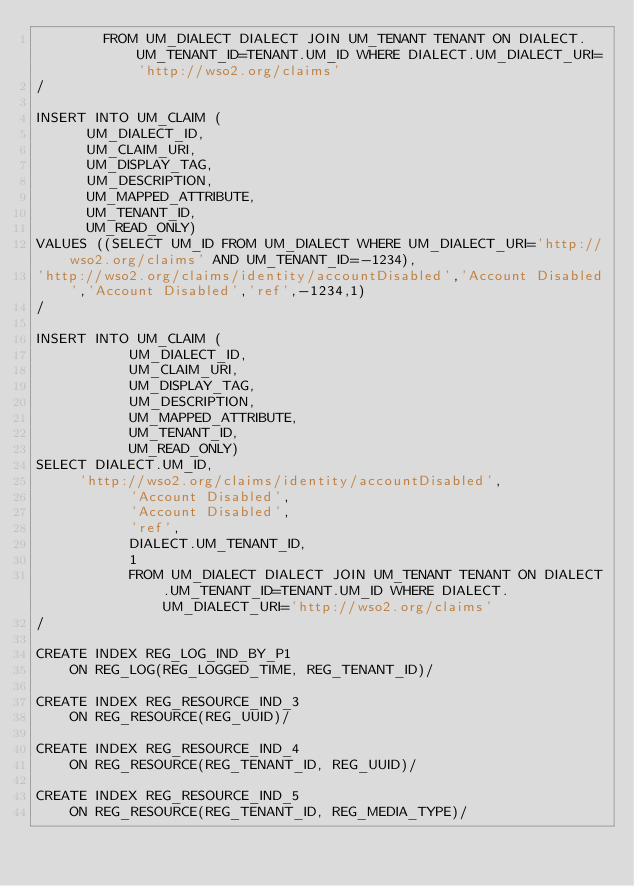Convert code to text. <code><loc_0><loc_0><loc_500><loc_500><_SQL_>        FROM UM_DIALECT DIALECT JOIN UM_TENANT TENANT ON DIALECT.UM_TENANT_ID=TENANT.UM_ID WHERE DIALECT.UM_DIALECT_URI='http://wso2.org/claims'
/

INSERT INTO UM_CLAIM (
      UM_DIALECT_ID,
      UM_CLAIM_URI,
      UM_DISPLAY_TAG,
      UM_DESCRIPTION,
      UM_MAPPED_ATTRIBUTE,
      UM_TENANT_ID,
      UM_READ_ONLY)
VALUES ((SELECT UM_ID FROM UM_DIALECT WHERE UM_DIALECT_URI='http://wso2.org/claims' AND UM_TENANT_ID=-1234),
'http://wso2.org/claims/identity/accountDisabled','Account Disabled','Account Disabled','ref',-1234,1)
/

INSERT INTO UM_CLAIM (
           UM_DIALECT_ID,
           UM_CLAIM_URI,
           UM_DISPLAY_TAG,
           UM_DESCRIPTION,
           UM_MAPPED_ATTRIBUTE,
           UM_TENANT_ID,
           UM_READ_ONLY)
SELECT DIALECT.UM_ID,
	   'http://wso2.org/claims/identity/accountDisabled',
           'Account Disabled',
           'Account Disabled',
           'ref',
	         DIALECT.UM_TENANT_ID,
           1
           FROM UM_DIALECT DIALECT JOIN UM_TENANT TENANT ON DIALECT.UM_TENANT_ID=TENANT.UM_ID WHERE DIALECT.UM_DIALECT_URI='http://wso2.org/claims'
/

CREATE INDEX REG_LOG_IND_BY_P1
    ON REG_LOG(REG_LOGGED_TIME, REG_TENANT_ID)/

CREATE INDEX REG_RESOURCE_IND_3
    ON REG_RESOURCE(REG_UUID)/

CREATE INDEX REG_RESOURCE_IND_4
    ON REG_RESOURCE(REG_TENANT_ID, REG_UUID)/

CREATE INDEX REG_RESOURCE_IND_5
    ON REG_RESOURCE(REG_TENANT_ID, REG_MEDIA_TYPE)/</code> 